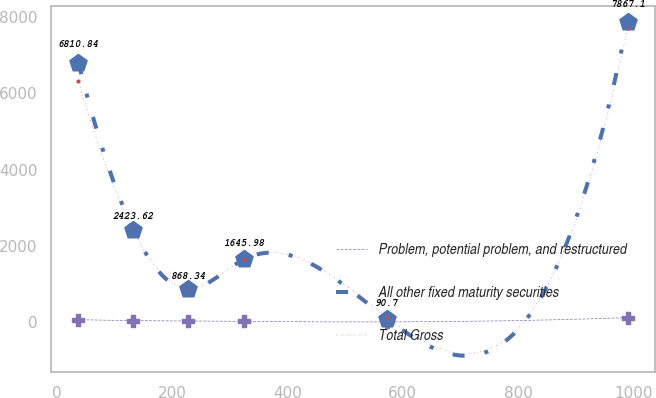<chart> <loc_0><loc_0><loc_500><loc_500><line_chart><ecel><fcel>Problem, potential problem, and restructured<fcel>All other fixed maturity securities<fcel>Total Gross<nl><fcel>37.49<fcel>65.14<fcel>6810.84<fcel>6327.71<nl><fcel>132.68<fcel>40.15<fcel>2423.62<fcel>2406.46<nl><fcel>227.87<fcel>28.85<fcel>868.34<fcel>890.76<nl><fcel>324.47<fcel>17.55<fcel>1645.98<fcel>1648.61<nl><fcel>572.37<fcel>6.25<fcel>90.7<fcel>132.91<nl><fcel>989.34<fcel>119.25<fcel>7867.1<fcel>7711.44<nl></chart> 